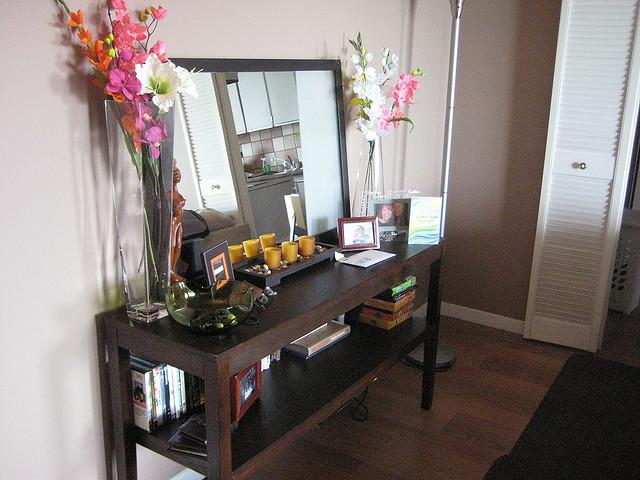What is behind the small table with the flowers? mirror 